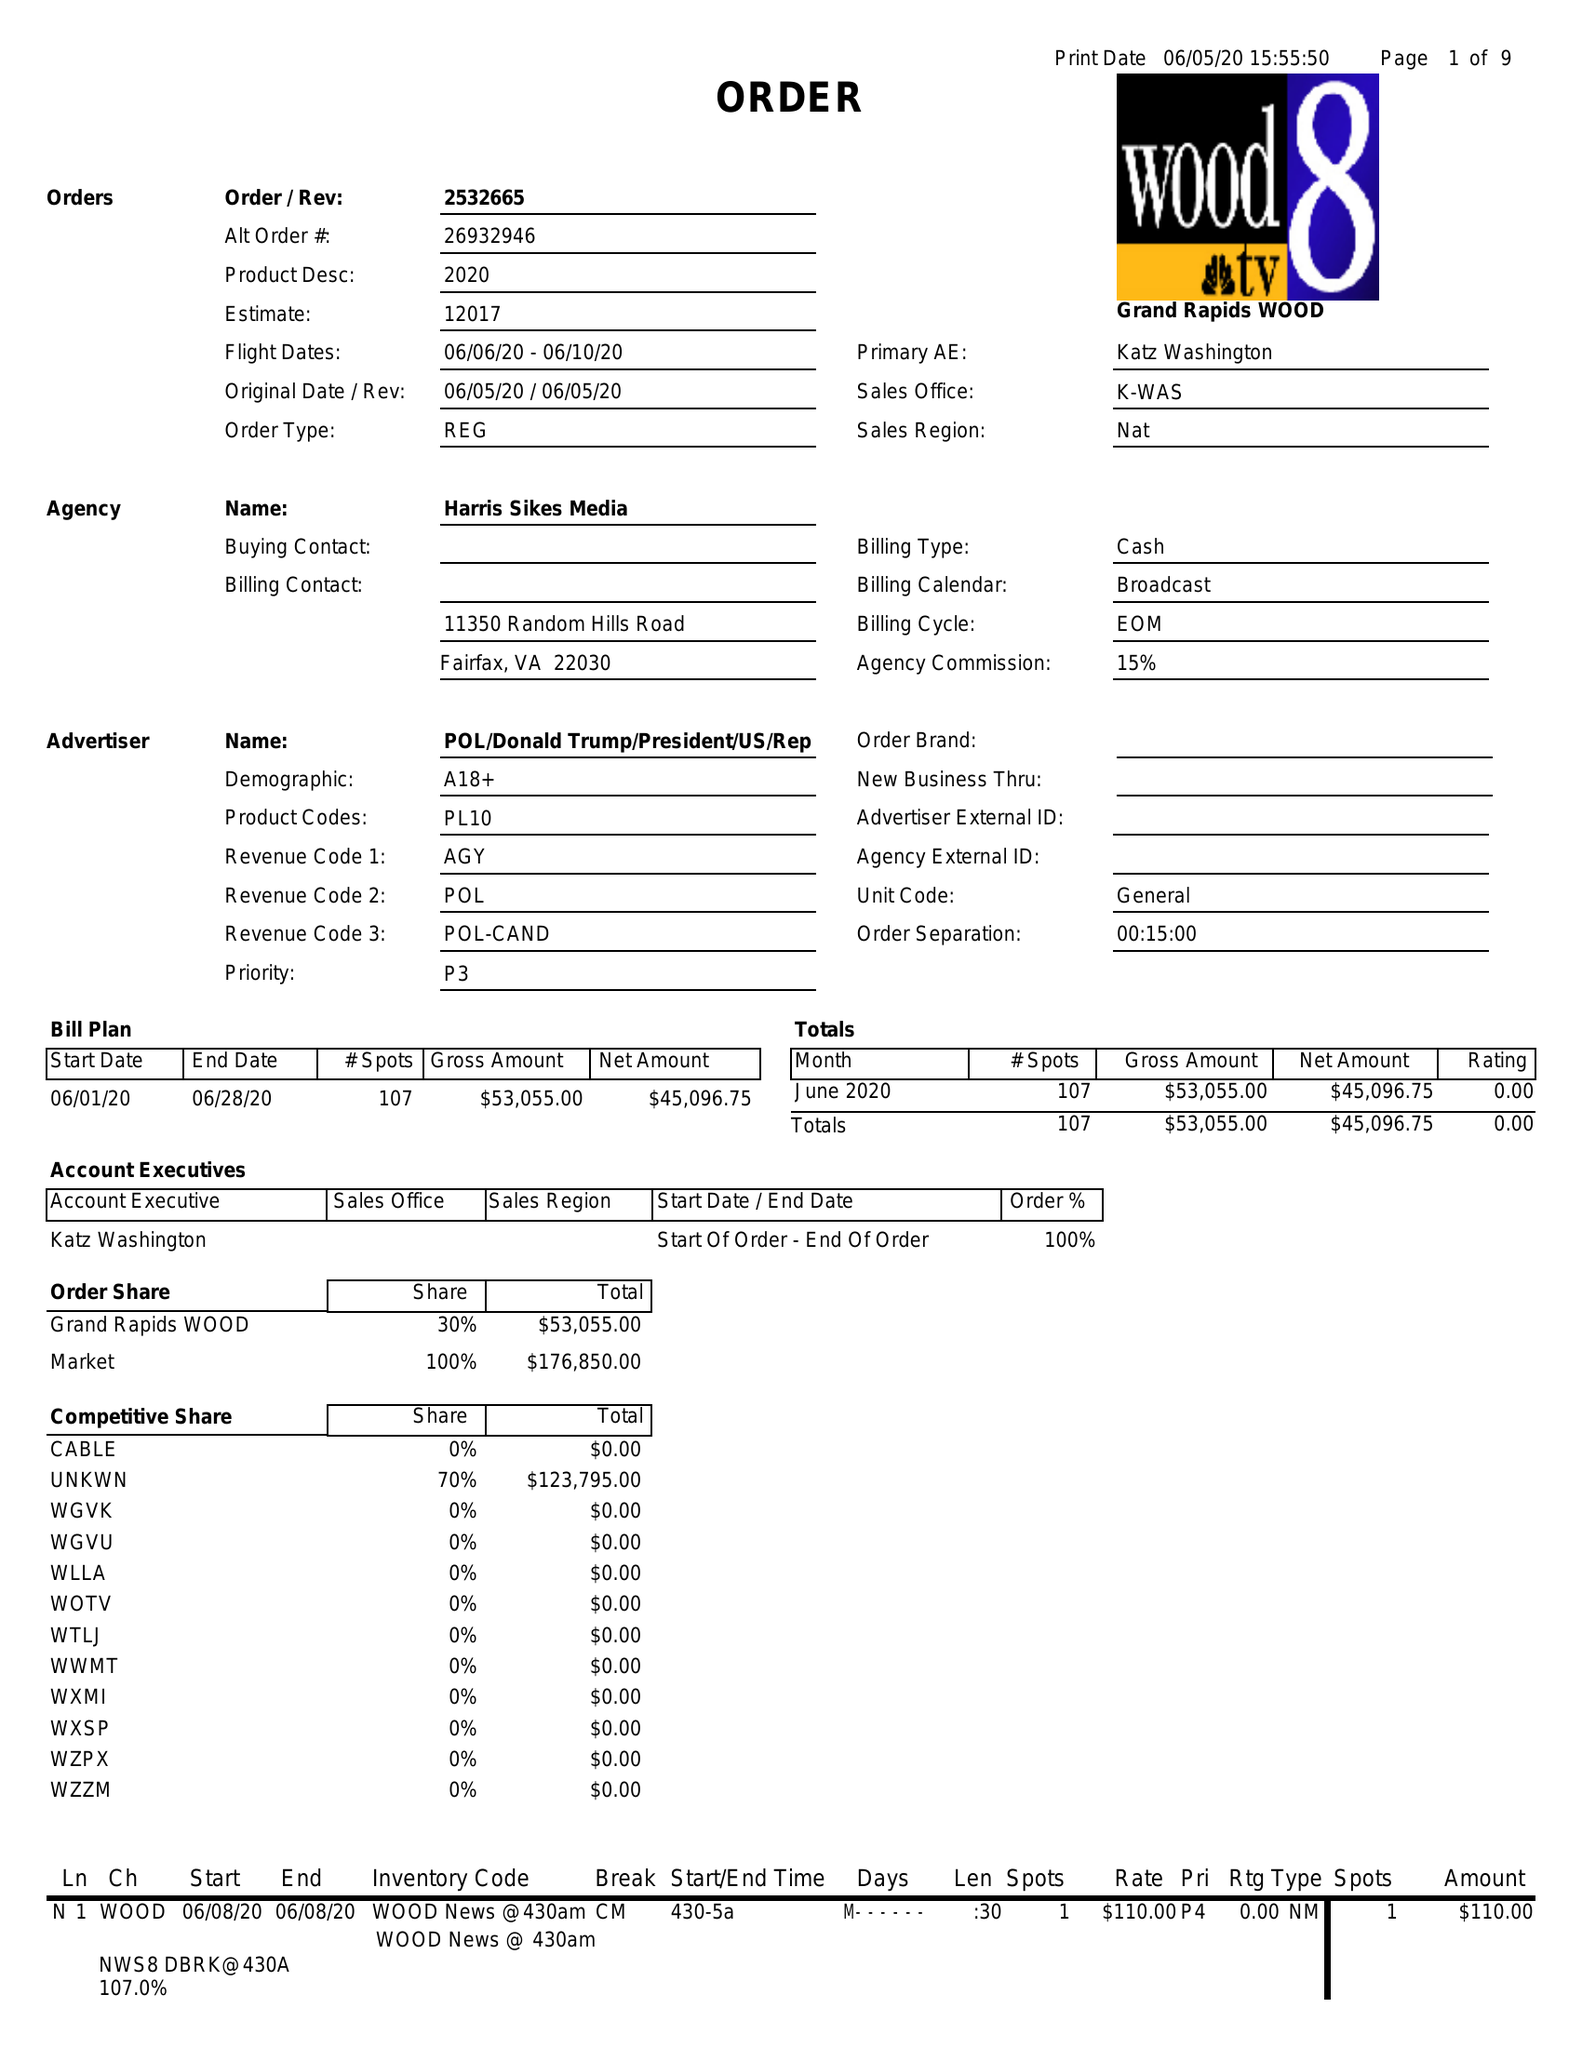What is the value for the advertiser?
Answer the question using a single word or phrase. POL/DONALDTRUMP/PRESIDENT/US/REP 